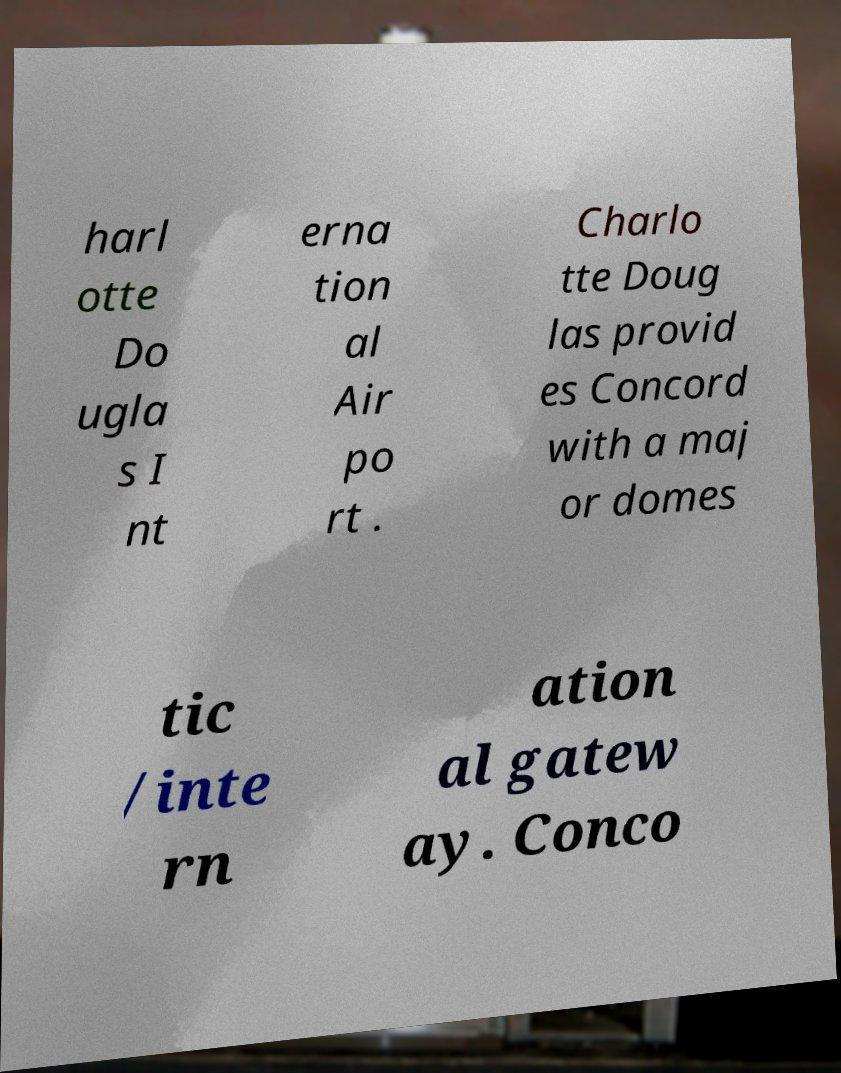For documentation purposes, I need the text within this image transcribed. Could you provide that? harl otte Do ugla s I nt erna tion al Air po rt . Charlo tte Doug las provid es Concord with a maj or domes tic /inte rn ation al gatew ay. Conco 